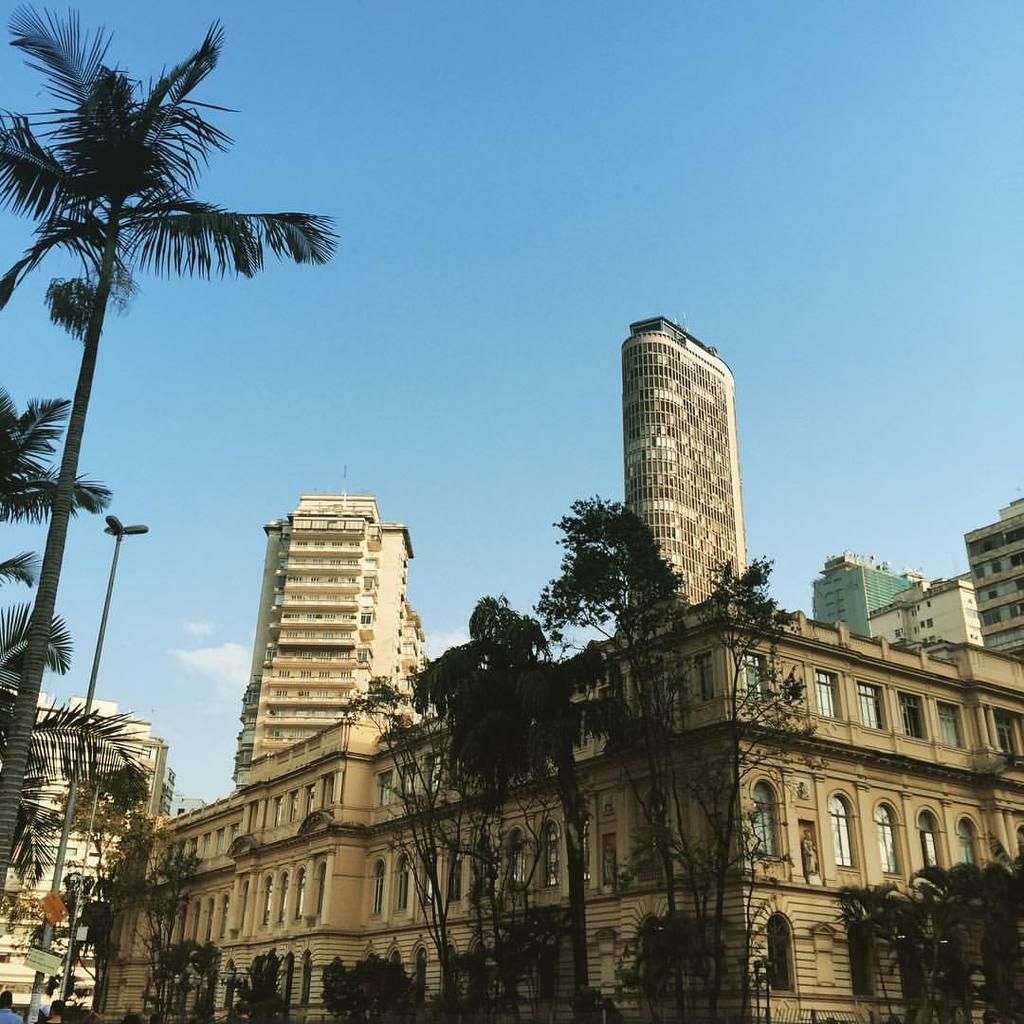How would you summarize this image in a sentence or two? In this image, we can see buildings, trees, poles, boards, some people and there are lights. At the top, there is sky. 